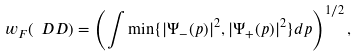<formula> <loc_0><loc_0><loc_500><loc_500>w _ { F } ( \ D D ) = \left ( \int \min \{ | \Psi _ { - } ( p ) | ^ { 2 } , | \Psi _ { + } ( p ) | ^ { 2 } \} d p \right ) ^ { 1 / 2 } ,</formula> 